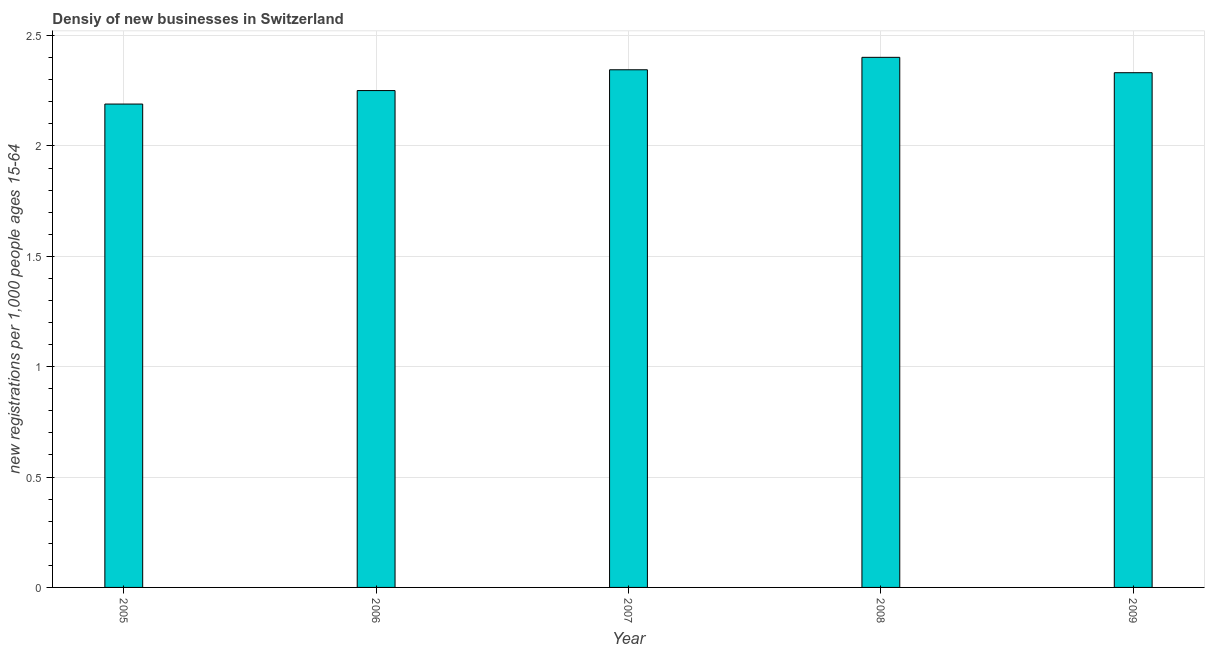Does the graph contain grids?
Keep it short and to the point. Yes. What is the title of the graph?
Offer a very short reply. Densiy of new businesses in Switzerland. What is the label or title of the Y-axis?
Offer a very short reply. New registrations per 1,0 people ages 15-64. What is the density of new business in 2006?
Offer a terse response. 2.25. Across all years, what is the maximum density of new business?
Give a very brief answer. 2.4. Across all years, what is the minimum density of new business?
Provide a succinct answer. 2.19. In which year was the density of new business maximum?
Offer a terse response. 2008. In which year was the density of new business minimum?
Your answer should be very brief. 2005. What is the sum of the density of new business?
Offer a terse response. 11.52. What is the difference between the density of new business in 2005 and 2009?
Keep it short and to the point. -0.14. What is the average density of new business per year?
Ensure brevity in your answer.  2.3. What is the median density of new business?
Make the answer very short. 2.33. In how many years, is the density of new business greater than 0.6 ?
Offer a very short reply. 5. Is the difference between the density of new business in 2005 and 2009 greater than the difference between any two years?
Ensure brevity in your answer.  No. What is the difference between the highest and the second highest density of new business?
Offer a terse response. 0.06. What is the difference between the highest and the lowest density of new business?
Keep it short and to the point. 0.21. In how many years, is the density of new business greater than the average density of new business taken over all years?
Provide a succinct answer. 3. How many bars are there?
Make the answer very short. 5. Are all the bars in the graph horizontal?
Make the answer very short. No. How many years are there in the graph?
Your answer should be compact. 5. What is the difference between two consecutive major ticks on the Y-axis?
Provide a succinct answer. 0.5. Are the values on the major ticks of Y-axis written in scientific E-notation?
Your answer should be very brief. No. What is the new registrations per 1,000 people ages 15-64 in 2005?
Offer a very short reply. 2.19. What is the new registrations per 1,000 people ages 15-64 in 2006?
Provide a succinct answer. 2.25. What is the new registrations per 1,000 people ages 15-64 in 2007?
Your answer should be compact. 2.35. What is the new registrations per 1,000 people ages 15-64 of 2008?
Your answer should be compact. 2.4. What is the new registrations per 1,000 people ages 15-64 of 2009?
Offer a terse response. 2.33. What is the difference between the new registrations per 1,000 people ages 15-64 in 2005 and 2006?
Offer a terse response. -0.06. What is the difference between the new registrations per 1,000 people ages 15-64 in 2005 and 2007?
Provide a succinct answer. -0.16. What is the difference between the new registrations per 1,000 people ages 15-64 in 2005 and 2008?
Offer a very short reply. -0.21. What is the difference between the new registrations per 1,000 people ages 15-64 in 2005 and 2009?
Your response must be concise. -0.14. What is the difference between the new registrations per 1,000 people ages 15-64 in 2006 and 2007?
Make the answer very short. -0.09. What is the difference between the new registrations per 1,000 people ages 15-64 in 2006 and 2008?
Ensure brevity in your answer.  -0.15. What is the difference between the new registrations per 1,000 people ages 15-64 in 2006 and 2009?
Give a very brief answer. -0.08. What is the difference between the new registrations per 1,000 people ages 15-64 in 2007 and 2008?
Provide a succinct answer. -0.06. What is the difference between the new registrations per 1,000 people ages 15-64 in 2007 and 2009?
Keep it short and to the point. 0.01. What is the difference between the new registrations per 1,000 people ages 15-64 in 2008 and 2009?
Offer a terse response. 0.07. What is the ratio of the new registrations per 1,000 people ages 15-64 in 2005 to that in 2007?
Your answer should be compact. 0.93. What is the ratio of the new registrations per 1,000 people ages 15-64 in 2005 to that in 2008?
Your response must be concise. 0.91. What is the ratio of the new registrations per 1,000 people ages 15-64 in 2005 to that in 2009?
Provide a succinct answer. 0.94. What is the ratio of the new registrations per 1,000 people ages 15-64 in 2006 to that in 2008?
Ensure brevity in your answer.  0.94. What is the ratio of the new registrations per 1,000 people ages 15-64 in 2006 to that in 2009?
Ensure brevity in your answer.  0.96. What is the ratio of the new registrations per 1,000 people ages 15-64 in 2007 to that in 2008?
Your answer should be very brief. 0.98. What is the ratio of the new registrations per 1,000 people ages 15-64 in 2007 to that in 2009?
Your answer should be compact. 1.01. What is the ratio of the new registrations per 1,000 people ages 15-64 in 2008 to that in 2009?
Ensure brevity in your answer.  1.03. 